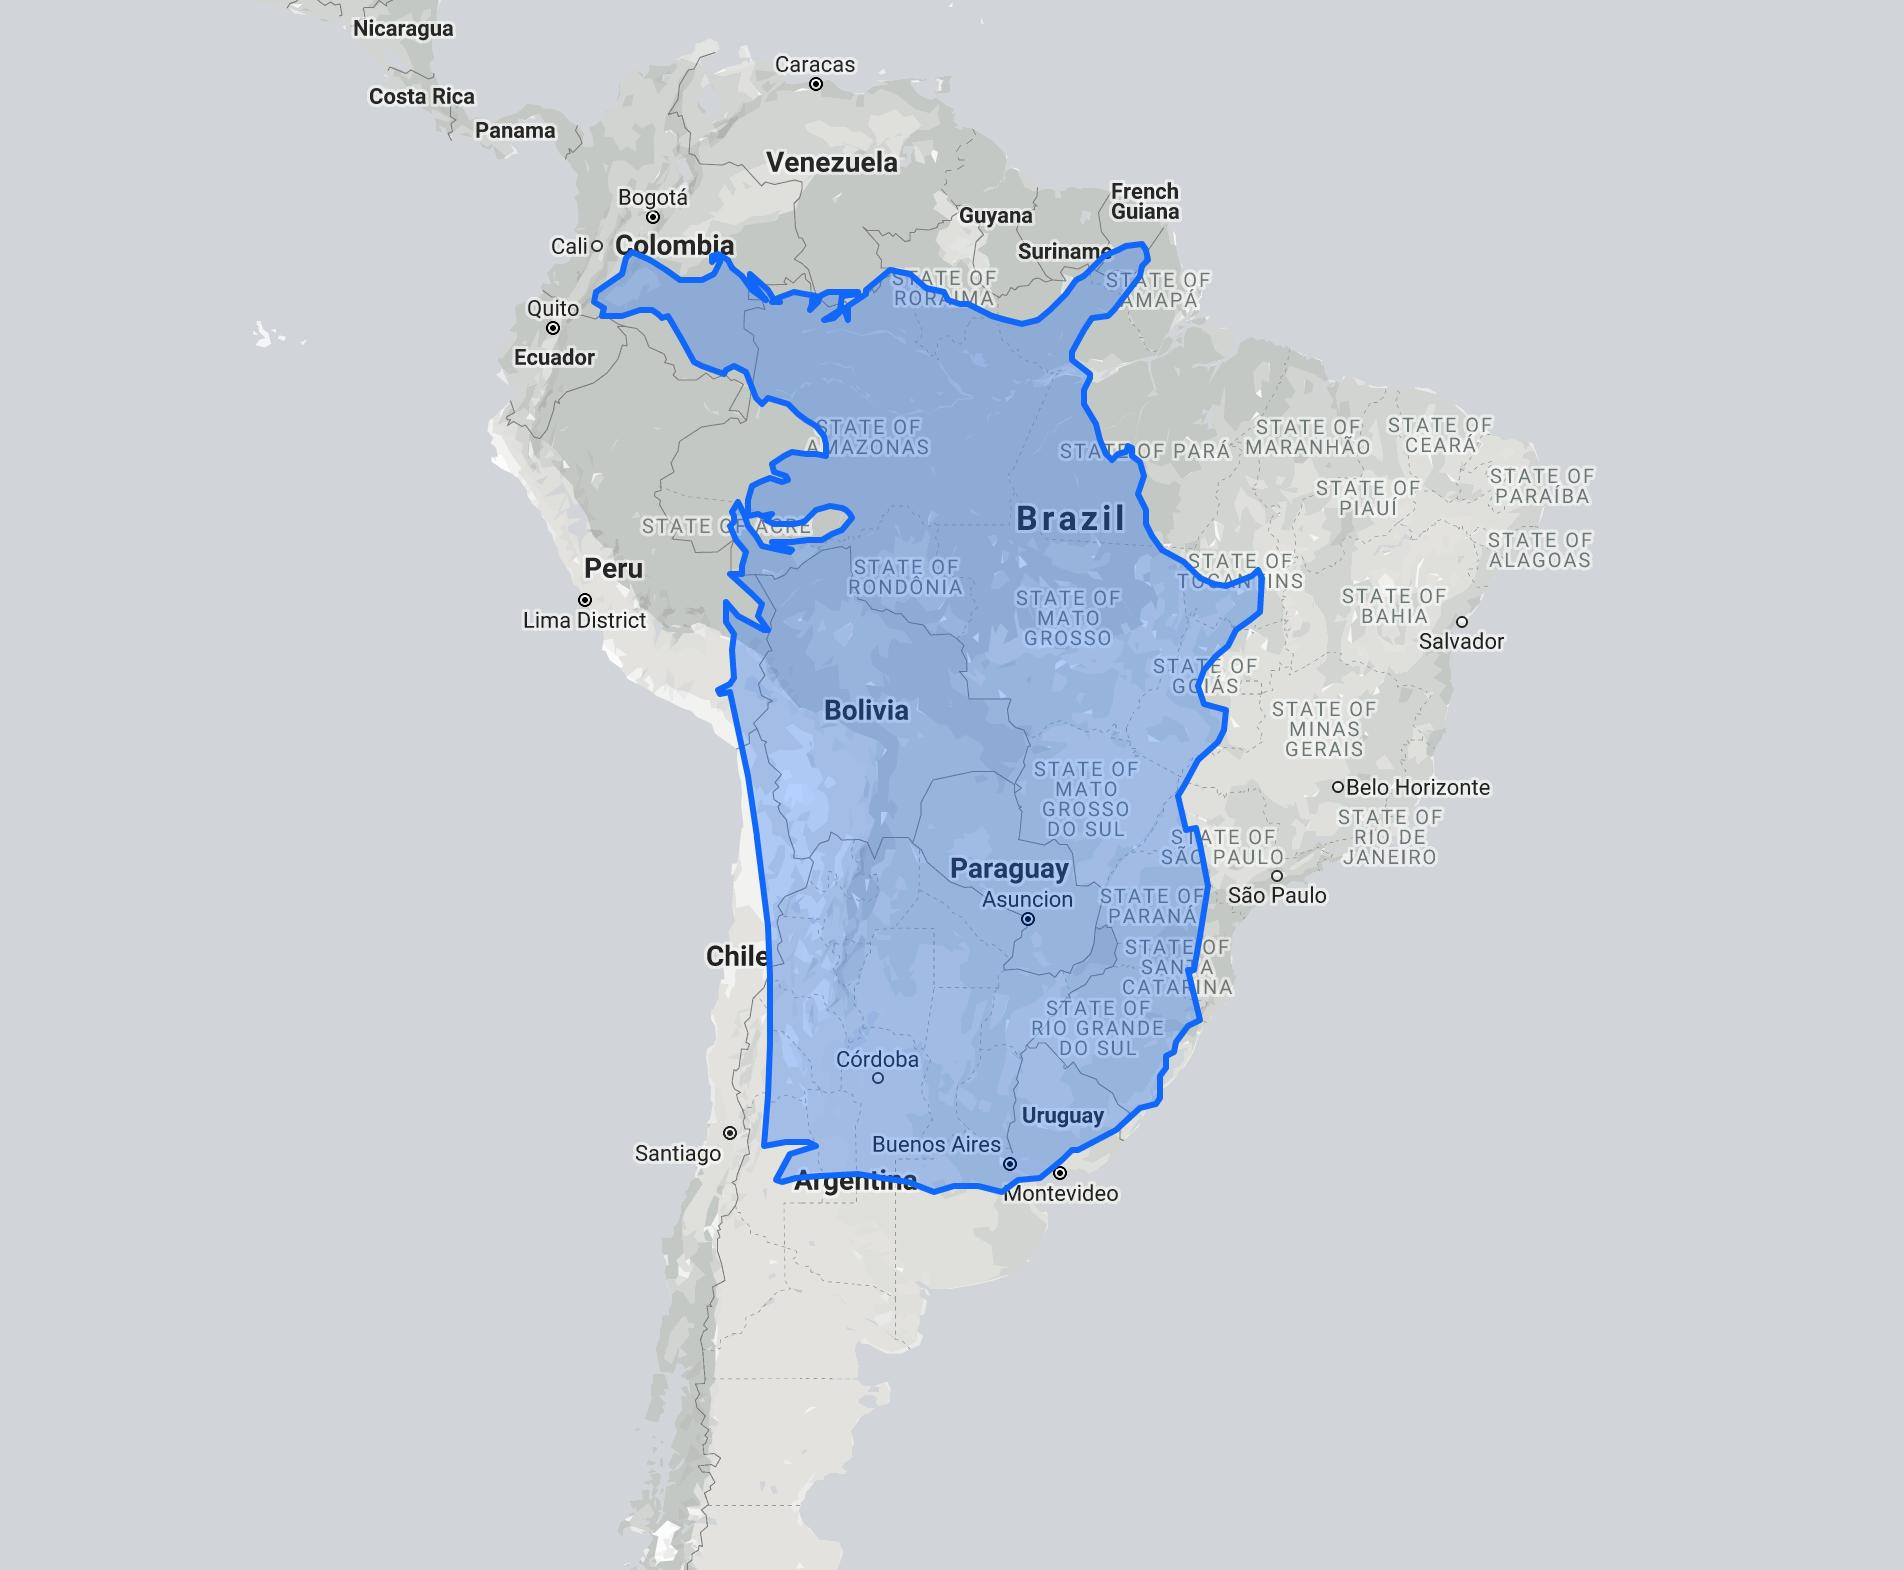Specify some key components in this picture. The country with the name "Brazil" written in large letters within the blue region on the map is located within the country. 